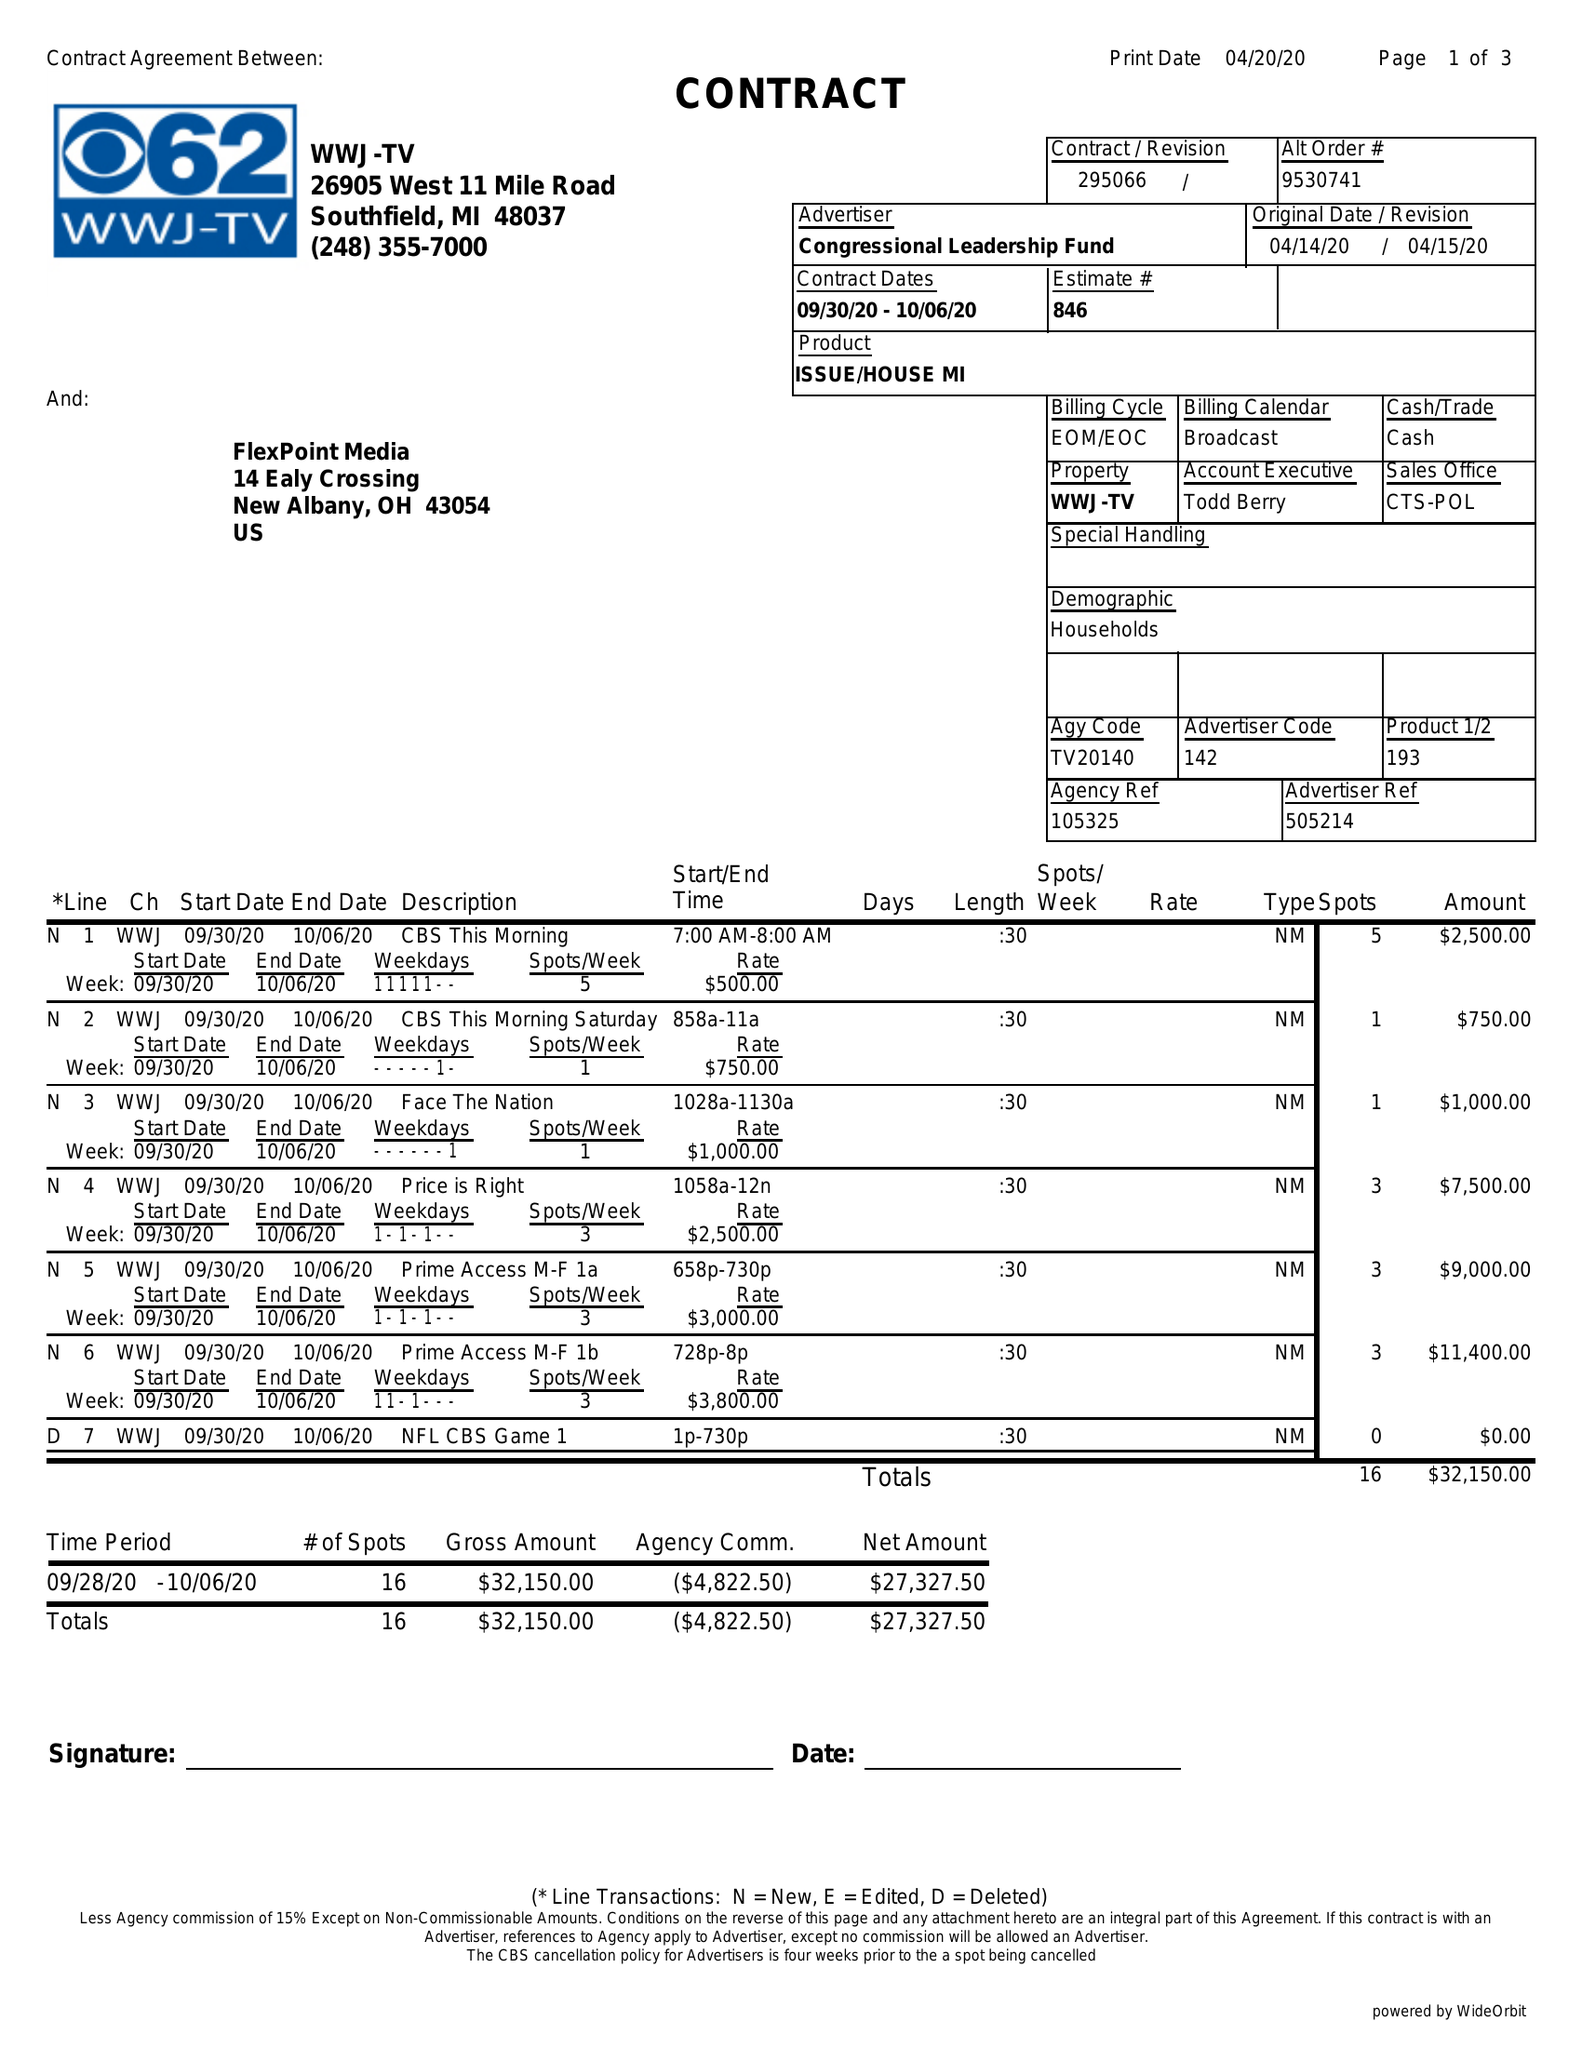What is the value for the flight_to?
Answer the question using a single word or phrase. 10/06/20 